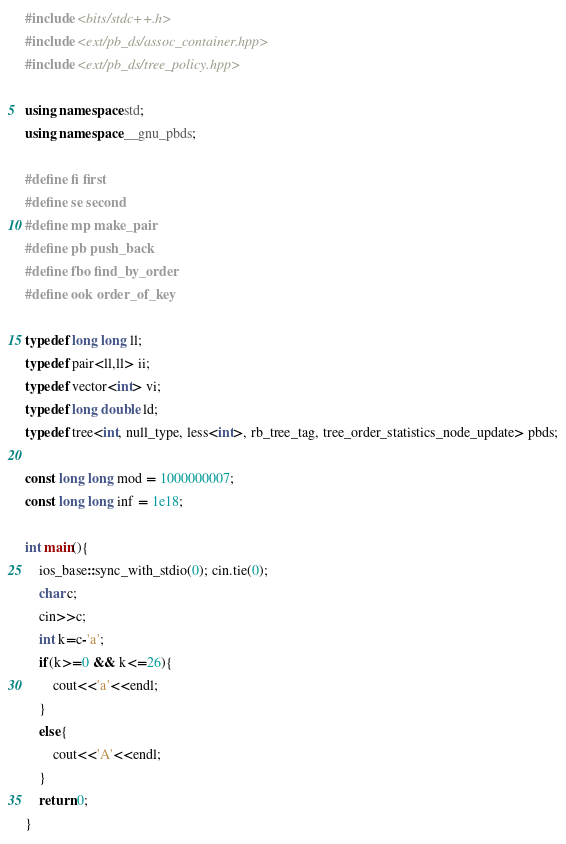Convert code to text. <code><loc_0><loc_0><loc_500><loc_500><_C++_>#include <bits/stdc++.h>
#include <ext/pb_ds/assoc_container.hpp>
#include <ext/pb_ds/tree_policy.hpp>

using namespace std;
using namespace __gnu_pbds;

#define fi first
#define se second
#define mp make_pair
#define pb push_back
#define fbo find_by_order
#define ook order_of_key

typedef long long ll;
typedef pair<ll,ll> ii;
typedef vector<int> vi;
typedef long double ld;
typedef tree<int, null_type, less<int>, rb_tree_tag, tree_order_statistics_node_update> pbds;

const long long mod = 1000000007;
const long long inf = 1e18;

int main(){
    ios_base::sync_with_stdio(0); cin.tie(0);
    char c;
    cin>>c;
    int k=c-'a';
    if(k>=0 && k<=26){
        cout<<'a'<<endl;
    }
    else{
        cout<<'A'<<endl;
    }
    return 0;
}
</code> 